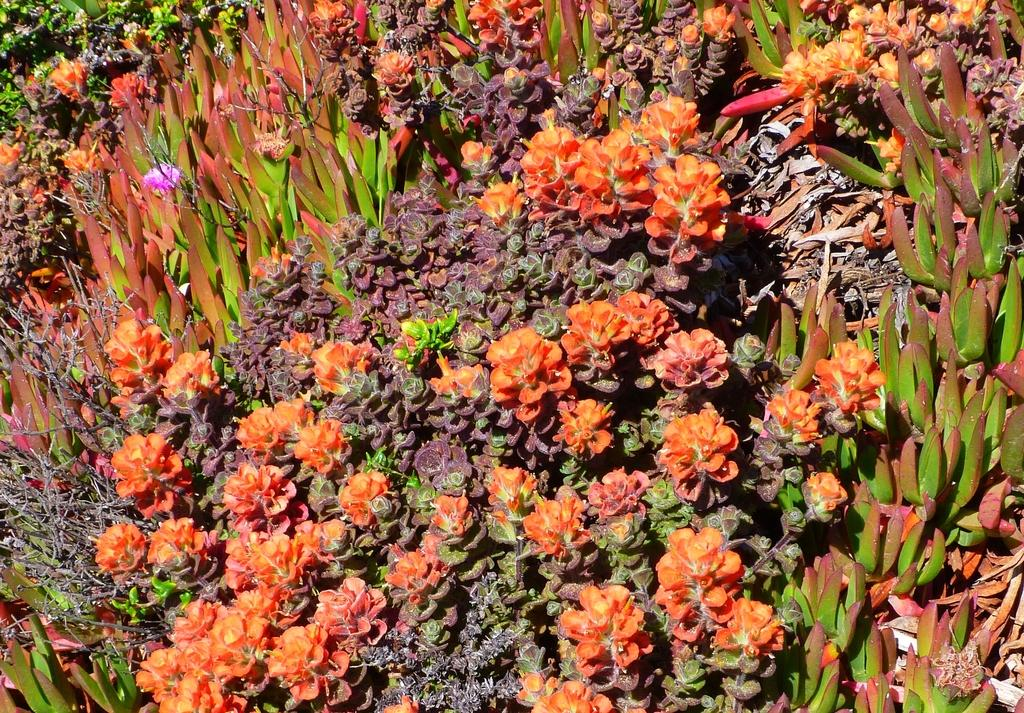What types of living organisms can be seen in the image? There are different types of plants in the image. Can you describe any specific features of the plants? One plant has a pink flower. What type of cup can be seen in the image? There is no cup present in the image; it features different types of plants. How does the hair of the plant move in the image? Plants do not have hair, so this question cannot be answered based on the information provided. 